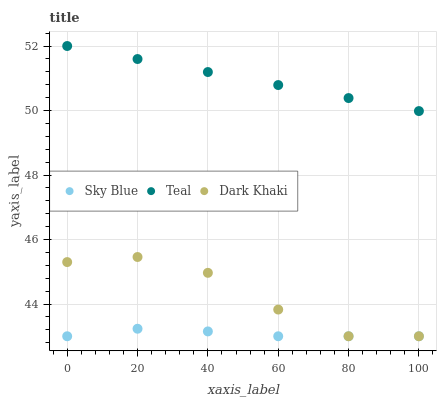Does Sky Blue have the minimum area under the curve?
Answer yes or no. Yes. Does Teal have the maximum area under the curve?
Answer yes or no. Yes. Does Teal have the minimum area under the curve?
Answer yes or no. No. Does Sky Blue have the maximum area under the curve?
Answer yes or no. No. Is Teal the smoothest?
Answer yes or no. Yes. Is Dark Khaki the roughest?
Answer yes or no. Yes. Is Sky Blue the smoothest?
Answer yes or no. No. Is Sky Blue the roughest?
Answer yes or no. No. Does Dark Khaki have the lowest value?
Answer yes or no. Yes. Does Teal have the lowest value?
Answer yes or no. No. Does Teal have the highest value?
Answer yes or no. Yes. Does Sky Blue have the highest value?
Answer yes or no. No. Is Sky Blue less than Teal?
Answer yes or no. Yes. Is Teal greater than Sky Blue?
Answer yes or no. Yes. Does Dark Khaki intersect Sky Blue?
Answer yes or no. Yes. Is Dark Khaki less than Sky Blue?
Answer yes or no. No. Is Dark Khaki greater than Sky Blue?
Answer yes or no. No. Does Sky Blue intersect Teal?
Answer yes or no. No. 